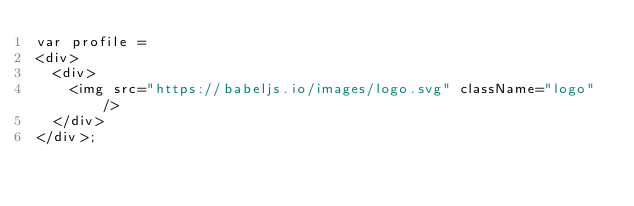Convert code to text. <code><loc_0><loc_0><loc_500><loc_500><_JavaScript_>var profile =
<div>
  <div>
    <img src="https://babeljs.io/images/logo.svg" className="logo" />    
  </div>
</div>;
</code> 